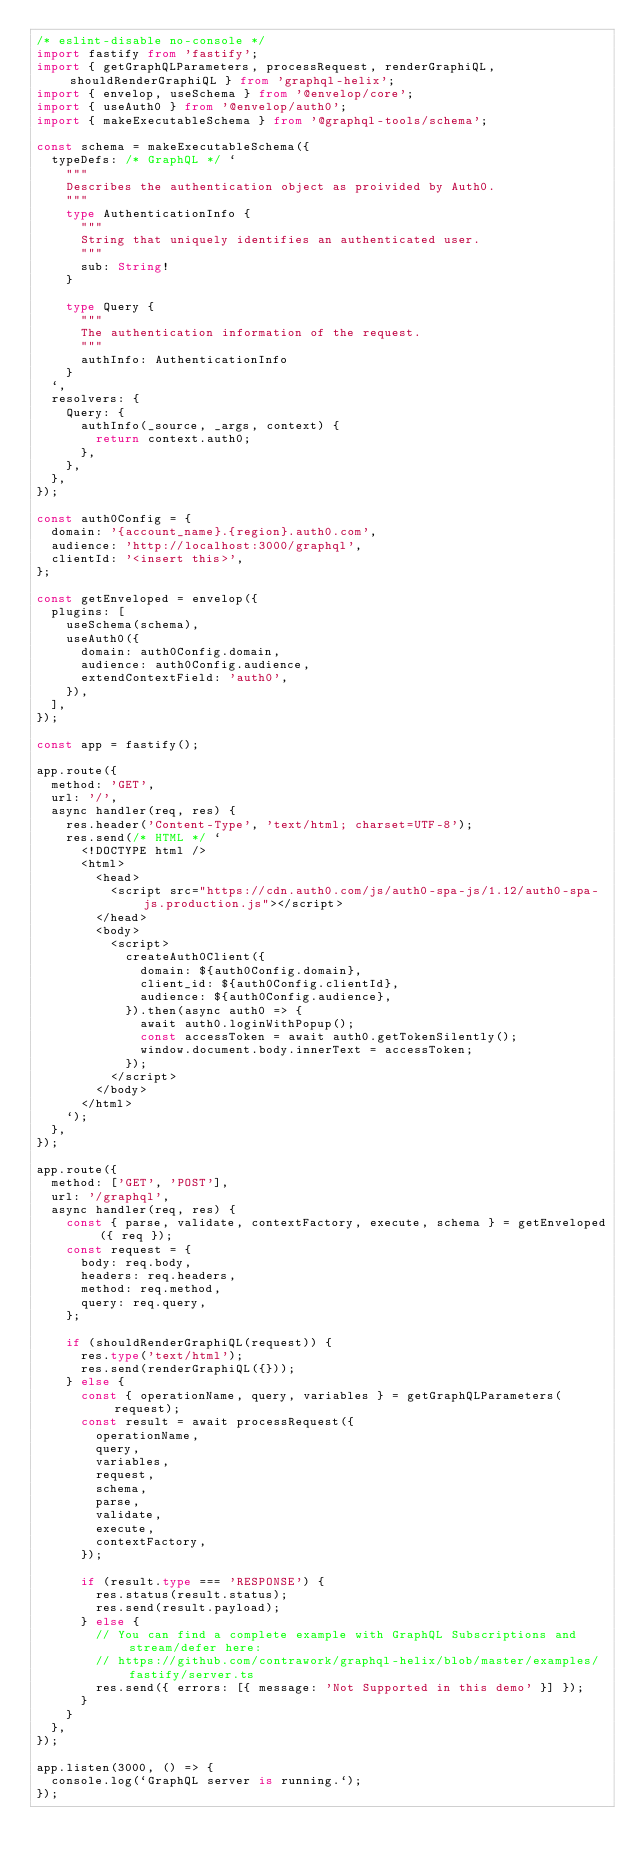<code> <loc_0><loc_0><loc_500><loc_500><_TypeScript_>/* eslint-disable no-console */
import fastify from 'fastify';
import { getGraphQLParameters, processRequest, renderGraphiQL, shouldRenderGraphiQL } from 'graphql-helix';
import { envelop, useSchema } from '@envelop/core';
import { useAuth0 } from '@envelop/auth0';
import { makeExecutableSchema } from '@graphql-tools/schema';

const schema = makeExecutableSchema({
  typeDefs: /* GraphQL */ `
    """
    Describes the authentication object as proivided by Auth0.
    """
    type AuthenticationInfo {
      """
      String that uniquely identifies an authenticated user.
      """
      sub: String!
    }

    type Query {
      """
      The authentication information of the request.
      """
      authInfo: AuthenticationInfo
    }
  `,
  resolvers: {
    Query: {
      authInfo(_source, _args, context) {
        return context.auth0;
      },
    },
  },
});

const auth0Config = {
  domain: '{account_name}.{region}.auth0.com',
  audience: 'http://localhost:3000/graphql',
  clientId: '<insert this>',
};

const getEnveloped = envelop({
  plugins: [
    useSchema(schema),
    useAuth0({
      domain: auth0Config.domain,
      audience: auth0Config.audience,
      extendContextField: 'auth0',
    }),
  ],
});

const app = fastify();

app.route({
  method: 'GET',
  url: '/',
  async handler(req, res) {
    res.header('Content-Type', 'text/html; charset=UTF-8');
    res.send(/* HTML */ `
      <!DOCTYPE html />
      <html>
        <head>
          <script src="https://cdn.auth0.com/js/auth0-spa-js/1.12/auth0-spa-js.production.js"></script>
        </head>
        <body>
          <script>
            createAuth0Client({
              domain: ${auth0Config.domain},
              client_id: ${auth0Config.clientId},
              audience: ${auth0Config.audience},
            }).then(async auth0 => {
              await auth0.loginWithPopup();
              const accessToken = await auth0.getTokenSilently();
              window.document.body.innerText = accessToken;
            });
          </script>
        </body>
      </html>
    `);
  },
});

app.route({
  method: ['GET', 'POST'],
  url: '/graphql',
  async handler(req, res) {
    const { parse, validate, contextFactory, execute, schema } = getEnveloped({ req });
    const request = {
      body: req.body,
      headers: req.headers,
      method: req.method,
      query: req.query,
    };

    if (shouldRenderGraphiQL(request)) {
      res.type('text/html');
      res.send(renderGraphiQL({}));
    } else {
      const { operationName, query, variables } = getGraphQLParameters(request);
      const result = await processRequest({
        operationName,
        query,
        variables,
        request,
        schema,
        parse,
        validate,
        execute,
        contextFactory,
      });

      if (result.type === 'RESPONSE') {
        res.status(result.status);
        res.send(result.payload);
      } else {
        // You can find a complete example with GraphQL Subscriptions and stream/defer here:
        // https://github.com/contrawork/graphql-helix/blob/master/examples/fastify/server.ts
        res.send({ errors: [{ message: 'Not Supported in this demo' }] });
      }
    }
  },
});

app.listen(3000, () => {
  console.log(`GraphQL server is running.`);
});
</code> 